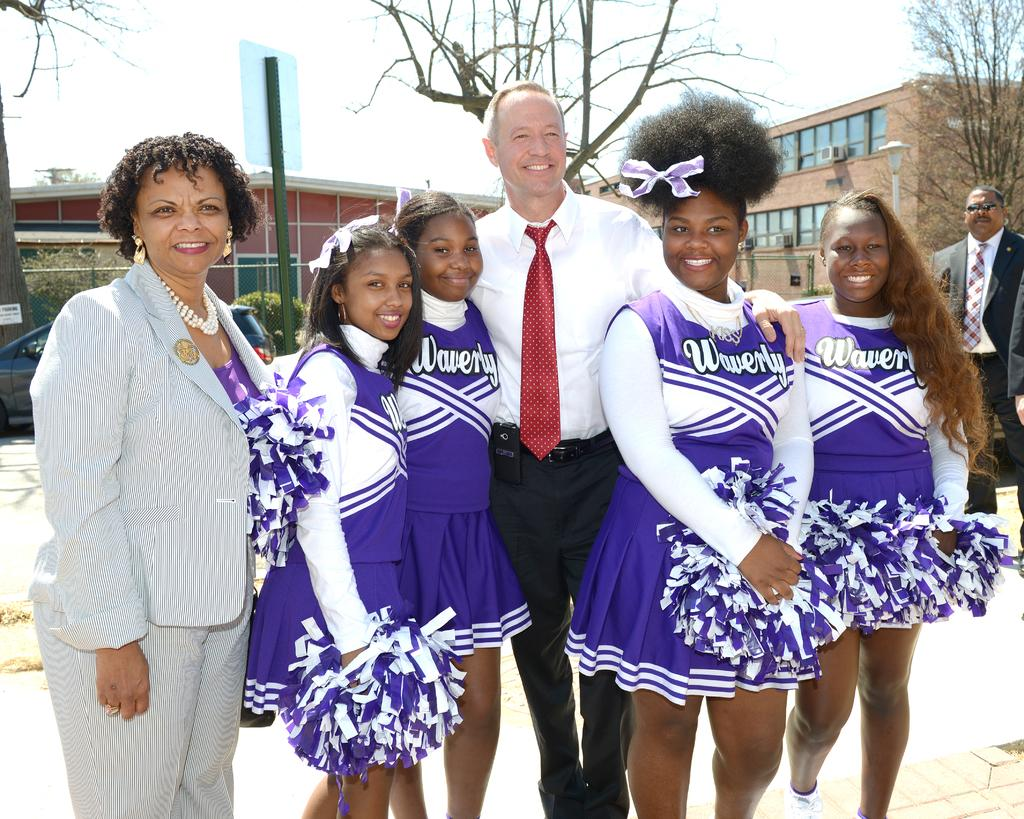Provide a one-sentence caption for the provided image. Several cheerleaders are wearing purple uniforms, representing Waverly. 